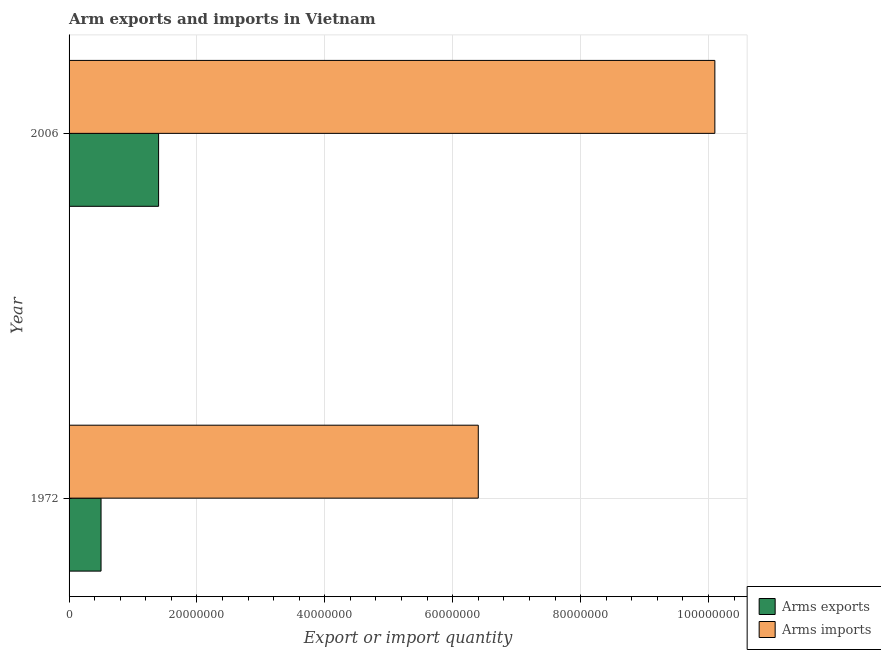Are the number of bars per tick equal to the number of legend labels?
Your answer should be compact. Yes. How many bars are there on the 1st tick from the bottom?
Offer a very short reply. 2. What is the label of the 2nd group of bars from the top?
Offer a very short reply. 1972. In how many cases, is the number of bars for a given year not equal to the number of legend labels?
Make the answer very short. 0. What is the arms exports in 2006?
Offer a terse response. 1.40e+07. Across all years, what is the maximum arms imports?
Give a very brief answer. 1.01e+08. Across all years, what is the minimum arms exports?
Provide a succinct answer. 5.00e+06. In which year was the arms imports minimum?
Offer a terse response. 1972. What is the total arms imports in the graph?
Provide a short and direct response. 1.65e+08. What is the difference between the arms imports in 1972 and that in 2006?
Offer a very short reply. -3.70e+07. What is the difference between the arms exports in 2006 and the arms imports in 1972?
Offer a terse response. -5.00e+07. What is the average arms imports per year?
Ensure brevity in your answer.  8.25e+07. In the year 2006, what is the difference between the arms imports and arms exports?
Keep it short and to the point. 8.70e+07. What is the ratio of the arms imports in 1972 to that in 2006?
Provide a short and direct response. 0.63. What does the 2nd bar from the top in 2006 represents?
Keep it short and to the point. Arms exports. What does the 2nd bar from the bottom in 1972 represents?
Keep it short and to the point. Arms imports. What is the difference between two consecutive major ticks on the X-axis?
Provide a succinct answer. 2.00e+07. Are the values on the major ticks of X-axis written in scientific E-notation?
Provide a short and direct response. No. How many legend labels are there?
Make the answer very short. 2. How are the legend labels stacked?
Offer a terse response. Vertical. What is the title of the graph?
Your response must be concise. Arm exports and imports in Vietnam. Does "Unregistered firms" appear as one of the legend labels in the graph?
Your response must be concise. No. What is the label or title of the X-axis?
Provide a short and direct response. Export or import quantity. What is the Export or import quantity of Arms exports in 1972?
Your answer should be very brief. 5.00e+06. What is the Export or import quantity of Arms imports in 1972?
Provide a succinct answer. 6.40e+07. What is the Export or import quantity in Arms exports in 2006?
Give a very brief answer. 1.40e+07. What is the Export or import quantity of Arms imports in 2006?
Your answer should be very brief. 1.01e+08. Across all years, what is the maximum Export or import quantity in Arms exports?
Make the answer very short. 1.40e+07. Across all years, what is the maximum Export or import quantity of Arms imports?
Provide a succinct answer. 1.01e+08. Across all years, what is the minimum Export or import quantity in Arms exports?
Provide a succinct answer. 5.00e+06. Across all years, what is the minimum Export or import quantity of Arms imports?
Keep it short and to the point. 6.40e+07. What is the total Export or import quantity of Arms exports in the graph?
Provide a succinct answer. 1.90e+07. What is the total Export or import quantity of Arms imports in the graph?
Your answer should be very brief. 1.65e+08. What is the difference between the Export or import quantity in Arms exports in 1972 and that in 2006?
Offer a terse response. -9.00e+06. What is the difference between the Export or import quantity in Arms imports in 1972 and that in 2006?
Provide a succinct answer. -3.70e+07. What is the difference between the Export or import quantity of Arms exports in 1972 and the Export or import quantity of Arms imports in 2006?
Your response must be concise. -9.60e+07. What is the average Export or import quantity of Arms exports per year?
Offer a terse response. 9.50e+06. What is the average Export or import quantity in Arms imports per year?
Offer a terse response. 8.25e+07. In the year 1972, what is the difference between the Export or import quantity of Arms exports and Export or import quantity of Arms imports?
Your response must be concise. -5.90e+07. In the year 2006, what is the difference between the Export or import quantity of Arms exports and Export or import quantity of Arms imports?
Give a very brief answer. -8.70e+07. What is the ratio of the Export or import quantity of Arms exports in 1972 to that in 2006?
Your answer should be compact. 0.36. What is the ratio of the Export or import quantity in Arms imports in 1972 to that in 2006?
Your answer should be compact. 0.63. What is the difference between the highest and the second highest Export or import quantity of Arms exports?
Provide a succinct answer. 9.00e+06. What is the difference between the highest and the second highest Export or import quantity in Arms imports?
Provide a succinct answer. 3.70e+07. What is the difference between the highest and the lowest Export or import quantity in Arms exports?
Ensure brevity in your answer.  9.00e+06. What is the difference between the highest and the lowest Export or import quantity in Arms imports?
Provide a succinct answer. 3.70e+07. 